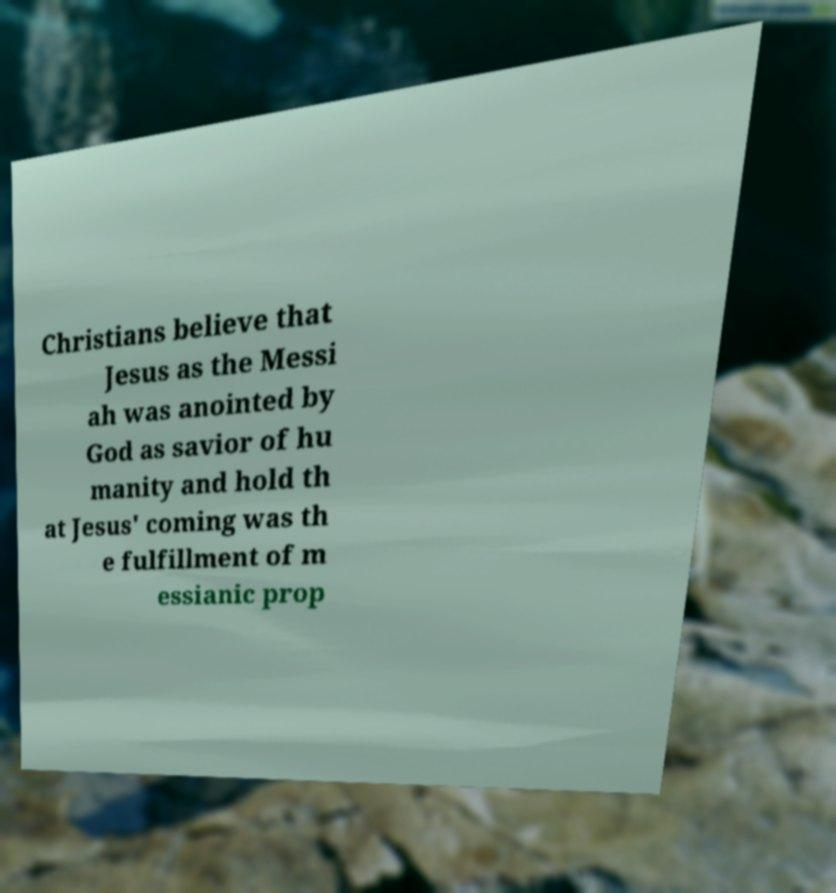Please read and relay the text visible in this image. What does it say? Christians believe that Jesus as the Messi ah was anointed by God as savior of hu manity and hold th at Jesus' coming was th e fulfillment of m essianic prop 